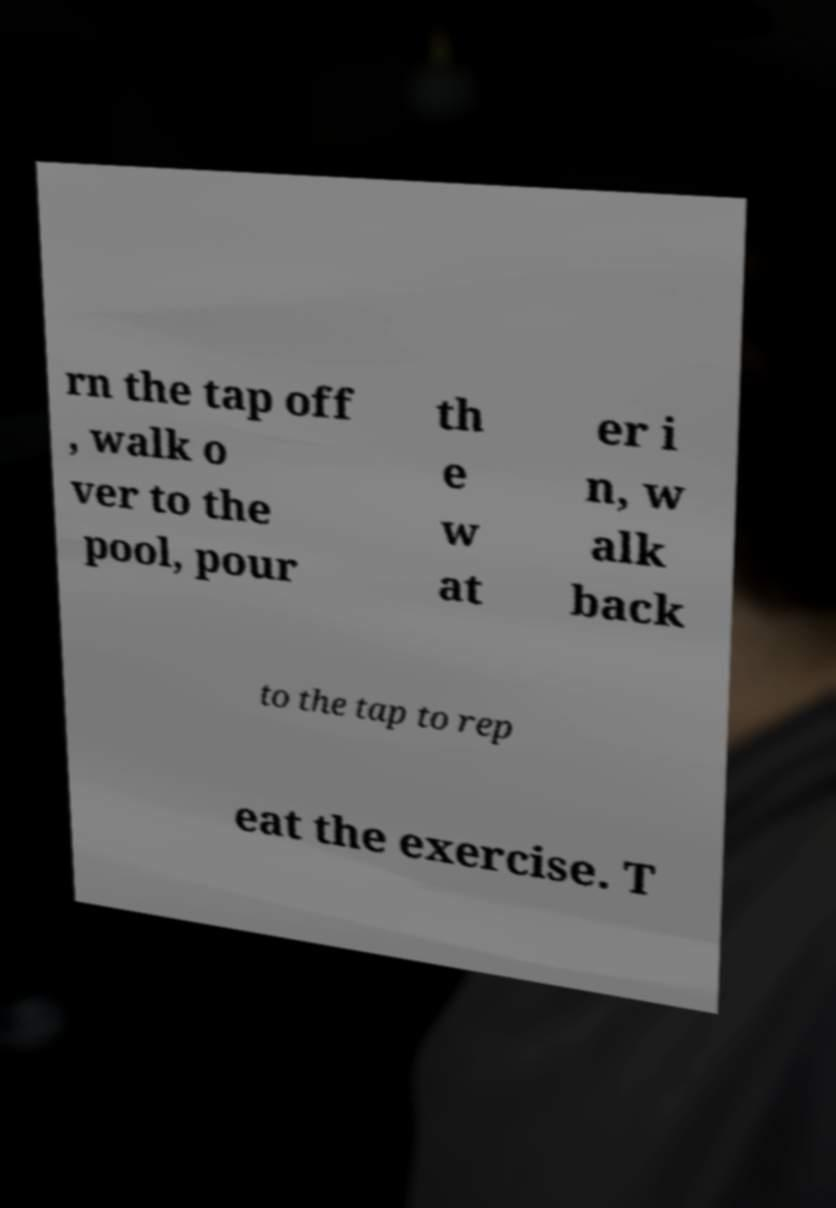For documentation purposes, I need the text within this image transcribed. Could you provide that? rn the tap off , walk o ver to the pool, pour th e w at er i n, w alk back to the tap to rep eat the exercise. T 